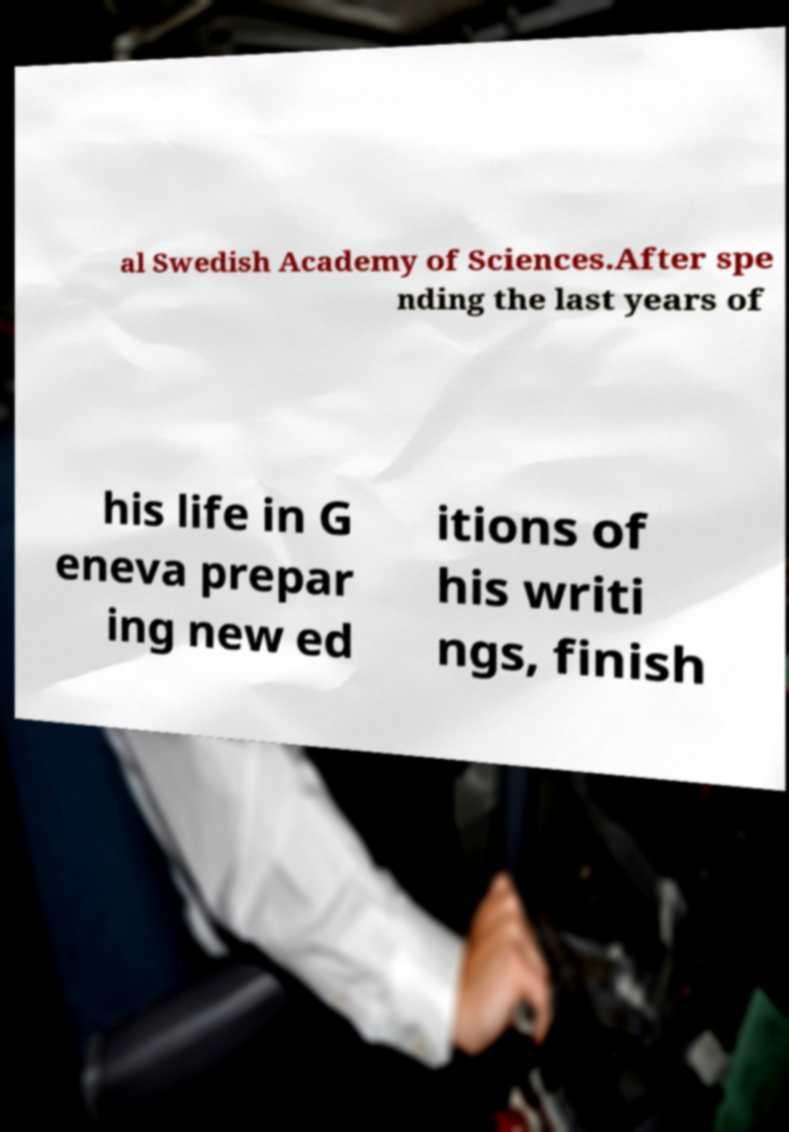I need the written content from this picture converted into text. Can you do that? al Swedish Academy of Sciences.After spe nding the last years of his life in G eneva prepar ing new ed itions of his writi ngs, finish 